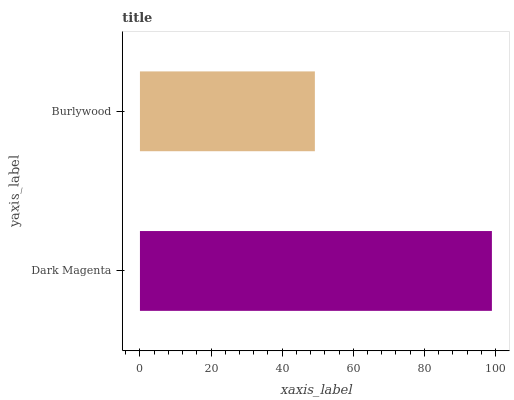Is Burlywood the minimum?
Answer yes or no. Yes. Is Dark Magenta the maximum?
Answer yes or no. Yes. Is Burlywood the maximum?
Answer yes or no. No. Is Dark Magenta greater than Burlywood?
Answer yes or no. Yes. Is Burlywood less than Dark Magenta?
Answer yes or no. Yes. Is Burlywood greater than Dark Magenta?
Answer yes or no. No. Is Dark Magenta less than Burlywood?
Answer yes or no. No. Is Dark Magenta the high median?
Answer yes or no. Yes. Is Burlywood the low median?
Answer yes or no. Yes. Is Burlywood the high median?
Answer yes or no. No. Is Dark Magenta the low median?
Answer yes or no. No. 